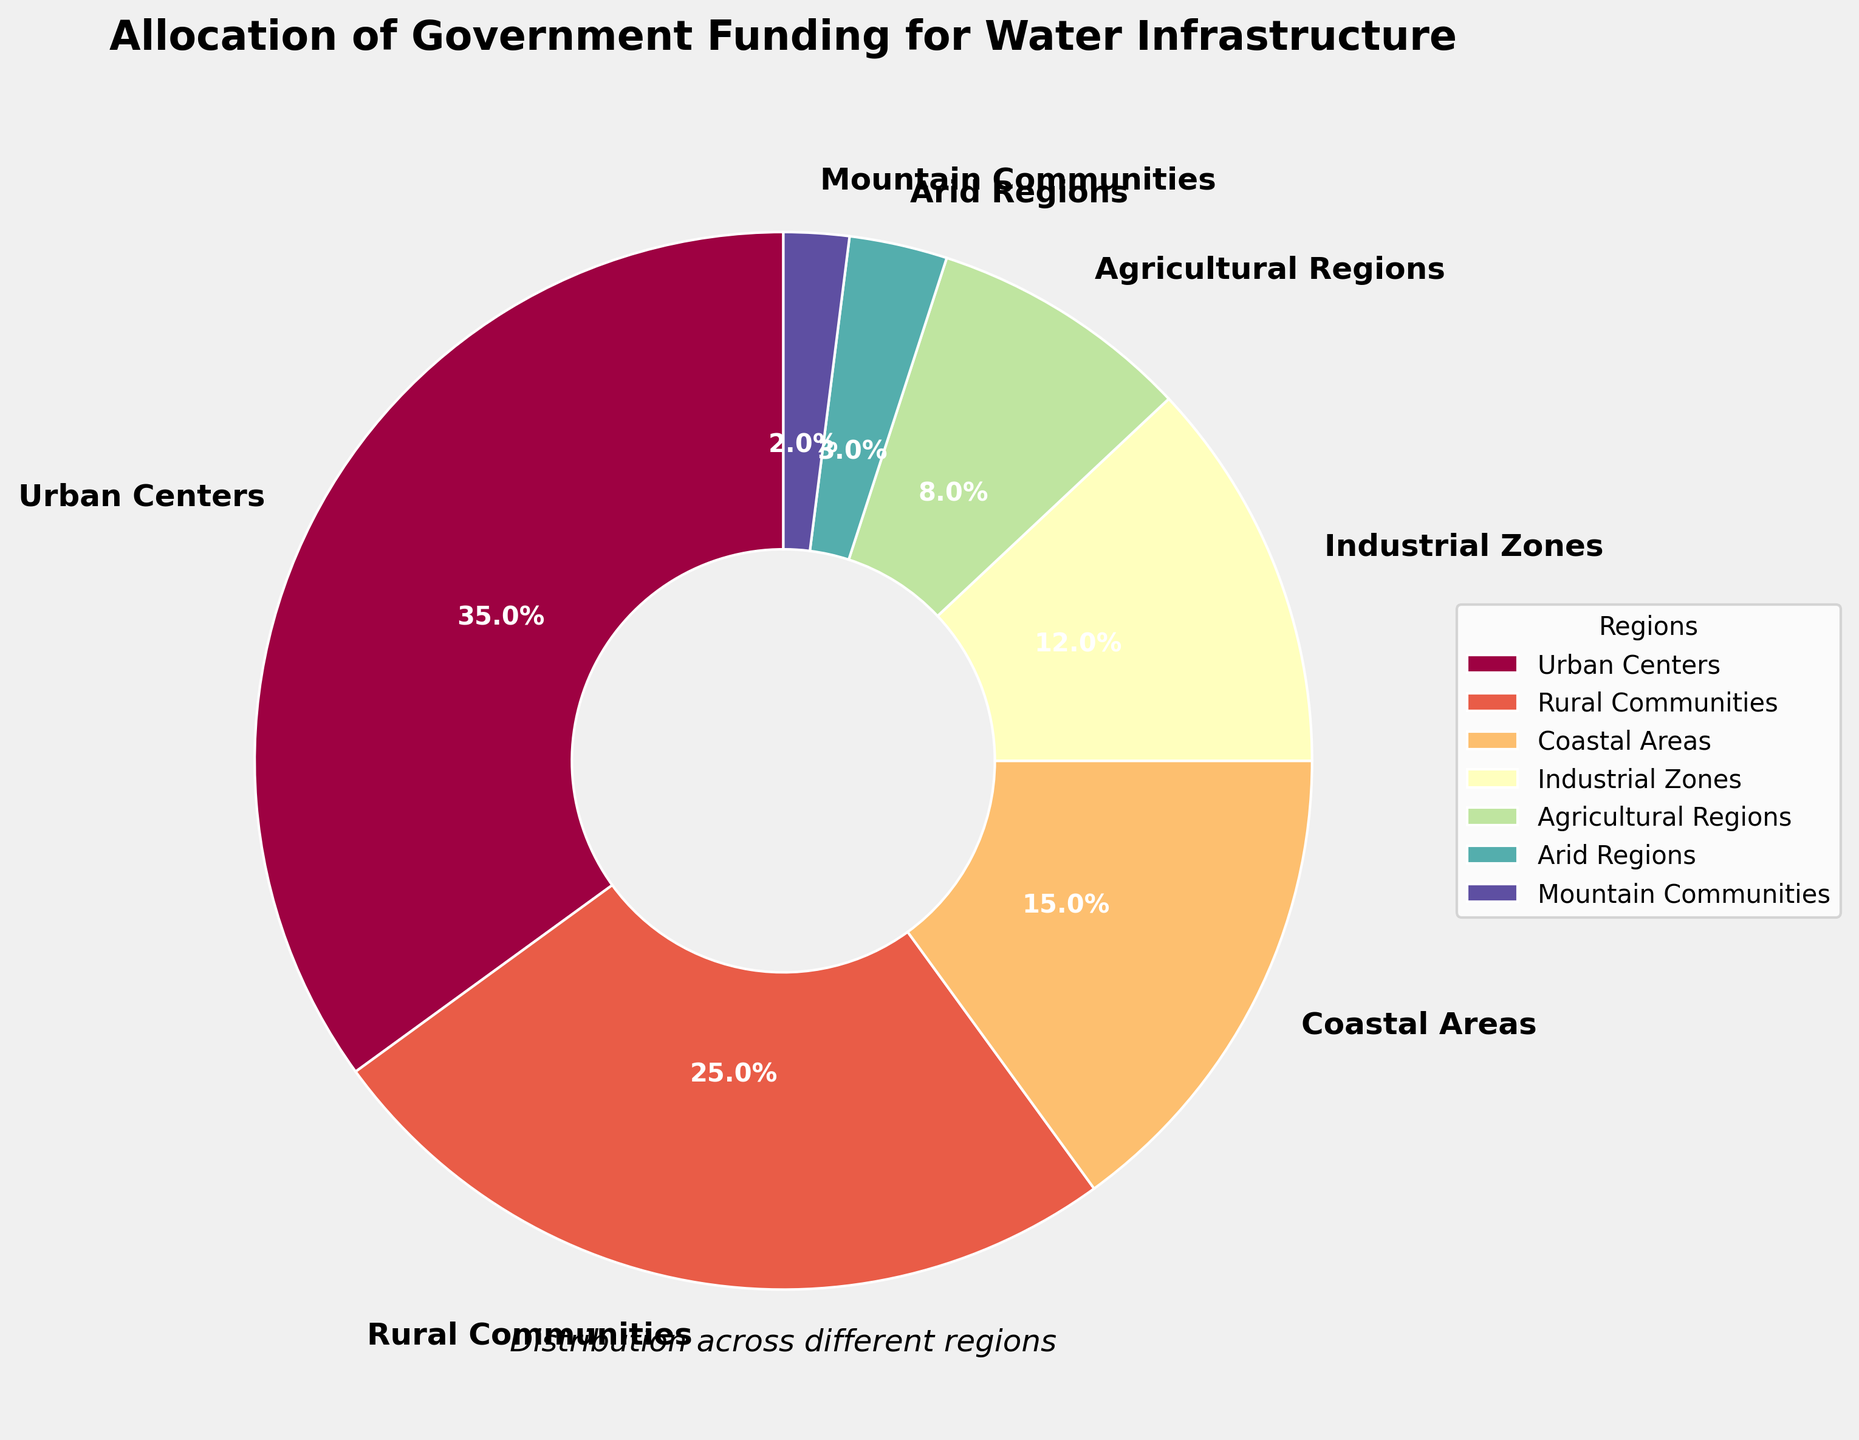Which region receives the highest allocation of government funding for water infrastructure? The figure shows the percentage of funding allocated to each region. The region with the highest percentage is represented by the largest section of the pie chart.
Answer: Urban Centers What is the combined funding allocation for Coastal Areas and Agricultural Regions? We need to add the percentages allocated to Coastal Areas and Agricultural Regions. According to the figure, Coastal Areas receive 15%, and Agricultural Regions receive 8%. The combined funding is 15% + 8% = 23%.
Answer: 23% Which region has a funding allocation closest to that of Industrial Zones? We compare the funding percentages close to 12% (Industrial Zones). The next closest percentage is Coastal Areas with 15%.
Answer: Coastal Areas How much more funding does Urban Centers receive compared to Mountain Communities? We need to find the difference in funding percentages between Urban Centers (35%) and Mountain Communities (2%). Subtract the smaller percentage from the larger one: 35% - 2% = 33%.
Answer: 33% Which three regions have the smallest allocation percentages? The smallest percentages can be identified by observing the smallest sections of the pie chart. The three regions with the smallest percentages are Mountain Communities (2%), Arid Regions (3%), and Agricultural Regions (8%).
Answer: Mountain Communities, Arid Regions, Agricultural Regions What is the average funding allocation for Industrial Zones, Agricultural Regions, and Arid Regions? First, we find the funding percentages of these regions: Industrial Zones (12%), Agricultural Regions (8%), and Arid Regions (3%). We then calculate the average: (12% + 8% + 3%) / 3 = 23% / 3 ≈ 7.67%.
Answer: 7.67% Is the funding for Rural Communities higher or lower than the total funding for Coastal Areas and Arid Regions combined? We compare the funding for Rural Communities (25%) with the combined funding for Coastal Areas (15%) and Arid Regions (3%). The combined funding is 15% + 3% = 18%. Since 25% is greater than 18%, the funding for Rural Communities is higher.
Answer: Higher Which region's funding allocation is visually represented by a significantly wider slice than that of Mountain Communities but still less than Urban Centers? We compare the widths of the pie slices. Rural Communities (25%) have a significantly wider slice than Mountain Communities (2%) but are still less than Urban Centers (35%).
Answer: Rural Communities If the funding for Industrial Zones is increased by 5% and for Agricultural Regions by 3%, what would the new total allocation for these two regions be? We need to calculate the new percentages: Industrial Zones (12% + 5% = 17%) and Agricultural Regions (8% + 3% = 11%). The new total allocation is 17% + 11% = 28%.
Answer: 28% Which region's funding allocation is represented in the pie chart using the color closest to blue? The figure uses a color map to represent regions. The region closest to blue in the color spectrum is used for Coastal Areas, typically shown in shades of blue.
Answer: Coastal Areas 